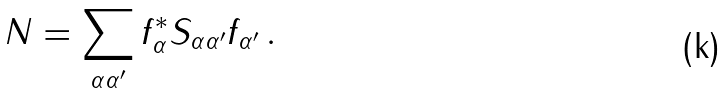<formula> <loc_0><loc_0><loc_500><loc_500>N = \sum _ { \alpha \alpha ^ { \prime } } f ^ { * } _ { \alpha } S _ { \alpha \alpha ^ { \prime } } f _ { \alpha ^ { \prime } } \, .</formula> 